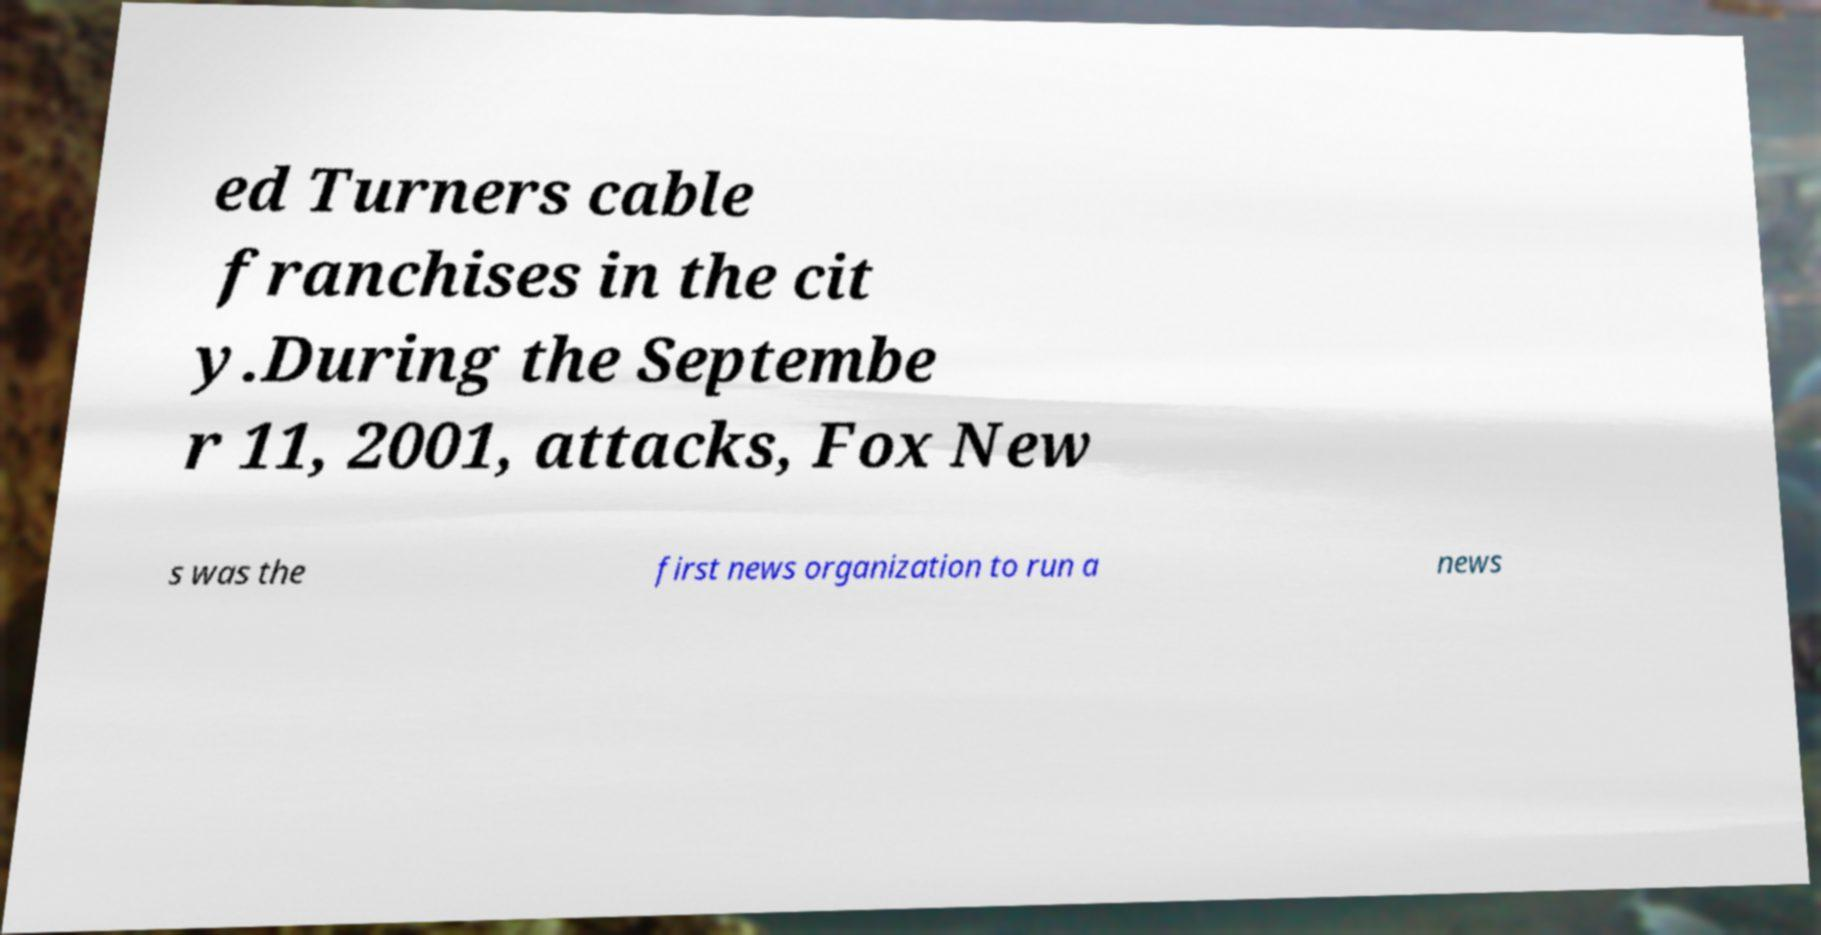What messages or text are displayed in this image? I need them in a readable, typed format. ed Turners cable franchises in the cit y.During the Septembe r 11, 2001, attacks, Fox New s was the first news organization to run a news 